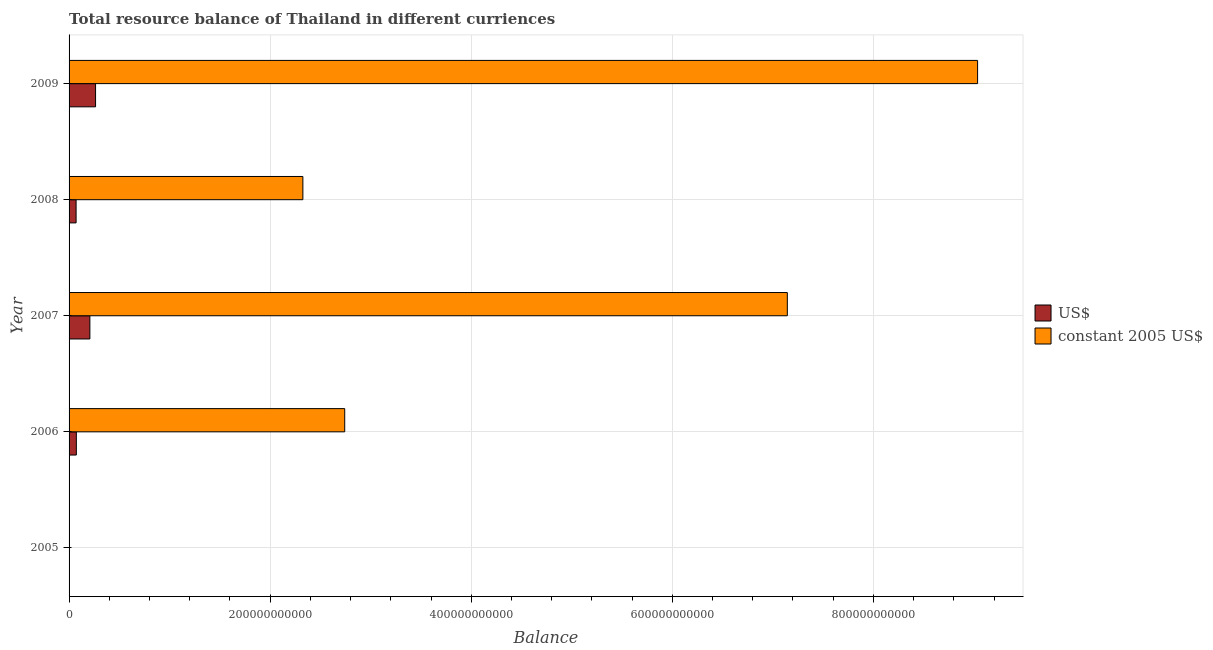How many different coloured bars are there?
Provide a short and direct response. 2. Are the number of bars per tick equal to the number of legend labels?
Provide a short and direct response. No. Are the number of bars on each tick of the Y-axis equal?
Your answer should be compact. No. How many bars are there on the 3rd tick from the top?
Provide a succinct answer. 2. What is the label of the 1st group of bars from the top?
Your response must be concise. 2009. In how many cases, is the number of bars for a given year not equal to the number of legend labels?
Give a very brief answer. 1. What is the resource balance in constant us$ in 2008?
Offer a very short reply. 2.33e+11. Across all years, what is the maximum resource balance in constant us$?
Your response must be concise. 9.04e+11. Across all years, what is the minimum resource balance in us$?
Your response must be concise. 0. In which year was the resource balance in constant us$ maximum?
Provide a short and direct response. 2009. What is the total resource balance in constant us$ in the graph?
Provide a succinct answer. 2.12e+12. What is the difference between the resource balance in us$ in 2007 and that in 2009?
Your response must be concise. -5.66e+09. What is the difference between the resource balance in us$ in 2009 and the resource balance in constant us$ in 2005?
Your answer should be very brief. 2.64e+1. What is the average resource balance in us$ per year?
Your answer should be compact. 1.23e+1. In the year 2009, what is the difference between the resource balance in constant us$ and resource balance in us$?
Ensure brevity in your answer.  8.77e+11. What is the ratio of the resource balance in constant us$ in 2006 to that in 2007?
Give a very brief answer. 0.38. Is the difference between the resource balance in constant us$ in 2007 and 2009 greater than the difference between the resource balance in us$ in 2007 and 2009?
Ensure brevity in your answer.  No. What is the difference between the highest and the second highest resource balance in constant us$?
Your answer should be compact. 1.89e+11. What is the difference between the highest and the lowest resource balance in us$?
Provide a succinct answer. 2.64e+1. In how many years, is the resource balance in us$ greater than the average resource balance in us$ taken over all years?
Keep it short and to the point. 2. How many bars are there?
Provide a succinct answer. 8. What is the difference between two consecutive major ticks on the X-axis?
Provide a short and direct response. 2.00e+11. Does the graph contain any zero values?
Provide a short and direct response. Yes. Where does the legend appear in the graph?
Your answer should be very brief. Center right. How many legend labels are there?
Your response must be concise. 2. What is the title of the graph?
Your answer should be compact. Total resource balance of Thailand in different curriences. What is the label or title of the X-axis?
Provide a short and direct response. Balance. What is the Balance in constant 2005 US$ in 2005?
Offer a terse response. 0. What is the Balance of US$ in 2006?
Provide a succinct answer. 7.24e+09. What is the Balance in constant 2005 US$ in 2006?
Provide a succinct answer. 2.74e+11. What is the Balance in US$ in 2007?
Offer a very short reply. 2.07e+1. What is the Balance of constant 2005 US$ in 2007?
Provide a succinct answer. 7.14e+11. What is the Balance in US$ in 2008?
Make the answer very short. 6.98e+09. What is the Balance of constant 2005 US$ in 2008?
Your response must be concise. 2.33e+11. What is the Balance in US$ in 2009?
Offer a terse response. 2.64e+1. What is the Balance of constant 2005 US$ in 2009?
Your answer should be very brief. 9.04e+11. Across all years, what is the maximum Balance of US$?
Give a very brief answer. 2.64e+1. Across all years, what is the maximum Balance in constant 2005 US$?
Your response must be concise. 9.04e+11. What is the total Balance in US$ in the graph?
Ensure brevity in your answer.  6.13e+1. What is the total Balance of constant 2005 US$ in the graph?
Provide a short and direct response. 2.12e+12. What is the difference between the Balance in US$ in 2006 and that in 2007?
Your answer should be compact. -1.35e+1. What is the difference between the Balance in constant 2005 US$ in 2006 and that in 2007?
Your response must be concise. -4.40e+11. What is the difference between the Balance of US$ in 2006 and that in 2008?
Offer a very short reply. 2.57e+08. What is the difference between the Balance of constant 2005 US$ in 2006 and that in 2008?
Your answer should be compact. 4.16e+1. What is the difference between the Balance in US$ in 2006 and that in 2009?
Your answer should be very brief. -1.91e+1. What is the difference between the Balance of constant 2005 US$ in 2006 and that in 2009?
Ensure brevity in your answer.  -6.30e+11. What is the difference between the Balance in US$ in 2007 and that in 2008?
Make the answer very short. 1.37e+1. What is the difference between the Balance in constant 2005 US$ in 2007 and that in 2008?
Your answer should be compact. 4.82e+11. What is the difference between the Balance in US$ in 2007 and that in 2009?
Offer a very short reply. -5.66e+09. What is the difference between the Balance in constant 2005 US$ in 2007 and that in 2009?
Your answer should be compact. -1.89e+11. What is the difference between the Balance of US$ in 2008 and that in 2009?
Your answer should be very brief. -1.94e+1. What is the difference between the Balance in constant 2005 US$ in 2008 and that in 2009?
Your response must be concise. -6.71e+11. What is the difference between the Balance of US$ in 2006 and the Balance of constant 2005 US$ in 2007?
Make the answer very short. -7.07e+11. What is the difference between the Balance of US$ in 2006 and the Balance of constant 2005 US$ in 2008?
Provide a short and direct response. -2.25e+11. What is the difference between the Balance in US$ in 2006 and the Balance in constant 2005 US$ in 2009?
Your answer should be compact. -8.96e+11. What is the difference between the Balance in US$ in 2007 and the Balance in constant 2005 US$ in 2008?
Provide a succinct answer. -2.12e+11. What is the difference between the Balance in US$ in 2007 and the Balance in constant 2005 US$ in 2009?
Offer a terse response. -8.83e+11. What is the difference between the Balance in US$ in 2008 and the Balance in constant 2005 US$ in 2009?
Offer a very short reply. -8.97e+11. What is the average Balance of US$ per year?
Your answer should be compact. 1.23e+1. What is the average Balance in constant 2005 US$ per year?
Ensure brevity in your answer.  4.25e+11. In the year 2006, what is the difference between the Balance of US$ and Balance of constant 2005 US$?
Your answer should be very brief. -2.67e+11. In the year 2007, what is the difference between the Balance of US$ and Balance of constant 2005 US$?
Your answer should be very brief. -6.94e+11. In the year 2008, what is the difference between the Balance of US$ and Balance of constant 2005 US$?
Your answer should be compact. -2.26e+11. In the year 2009, what is the difference between the Balance of US$ and Balance of constant 2005 US$?
Ensure brevity in your answer.  -8.77e+11. What is the ratio of the Balance of US$ in 2006 to that in 2007?
Your answer should be compact. 0.35. What is the ratio of the Balance of constant 2005 US$ in 2006 to that in 2007?
Your answer should be compact. 0.38. What is the ratio of the Balance of US$ in 2006 to that in 2008?
Keep it short and to the point. 1.04. What is the ratio of the Balance of constant 2005 US$ in 2006 to that in 2008?
Make the answer very short. 1.18. What is the ratio of the Balance in US$ in 2006 to that in 2009?
Keep it short and to the point. 0.27. What is the ratio of the Balance in constant 2005 US$ in 2006 to that in 2009?
Offer a terse response. 0.3. What is the ratio of the Balance in US$ in 2007 to that in 2008?
Offer a very short reply. 2.96. What is the ratio of the Balance in constant 2005 US$ in 2007 to that in 2008?
Give a very brief answer. 3.07. What is the ratio of the Balance of US$ in 2007 to that in 2009?
Make the answer very short. 0.79. What is the ratio of the Balance in constant 2005 US$ in 2007 to that in 2009?
Give a very brief answer. 0.79. What is the ratio of the Balance in US$ in 2008 to that in 2009?
Ensure brevity in your answer.  0.26. What is the ratio of the Balance in constant 2005 US$ in 2008 to that in 2009?
Your answer should be very brief. 0.26. What is the difference between the highest and the second highest Balance in US$?
Offer a very short reply. 5.66e+09. What is the difference between the highest and the second highest Balance of constant 2005 US$?
Offer a terse response. 1.89e+11. What is the difference between the highest and the lowest Balance in US$?
Your answer should be very brief. 2.64e+1. What is the difference between the highest and the lowest Balance of constant 2005 US$?
Offer a terse response. 9.04e+11. 